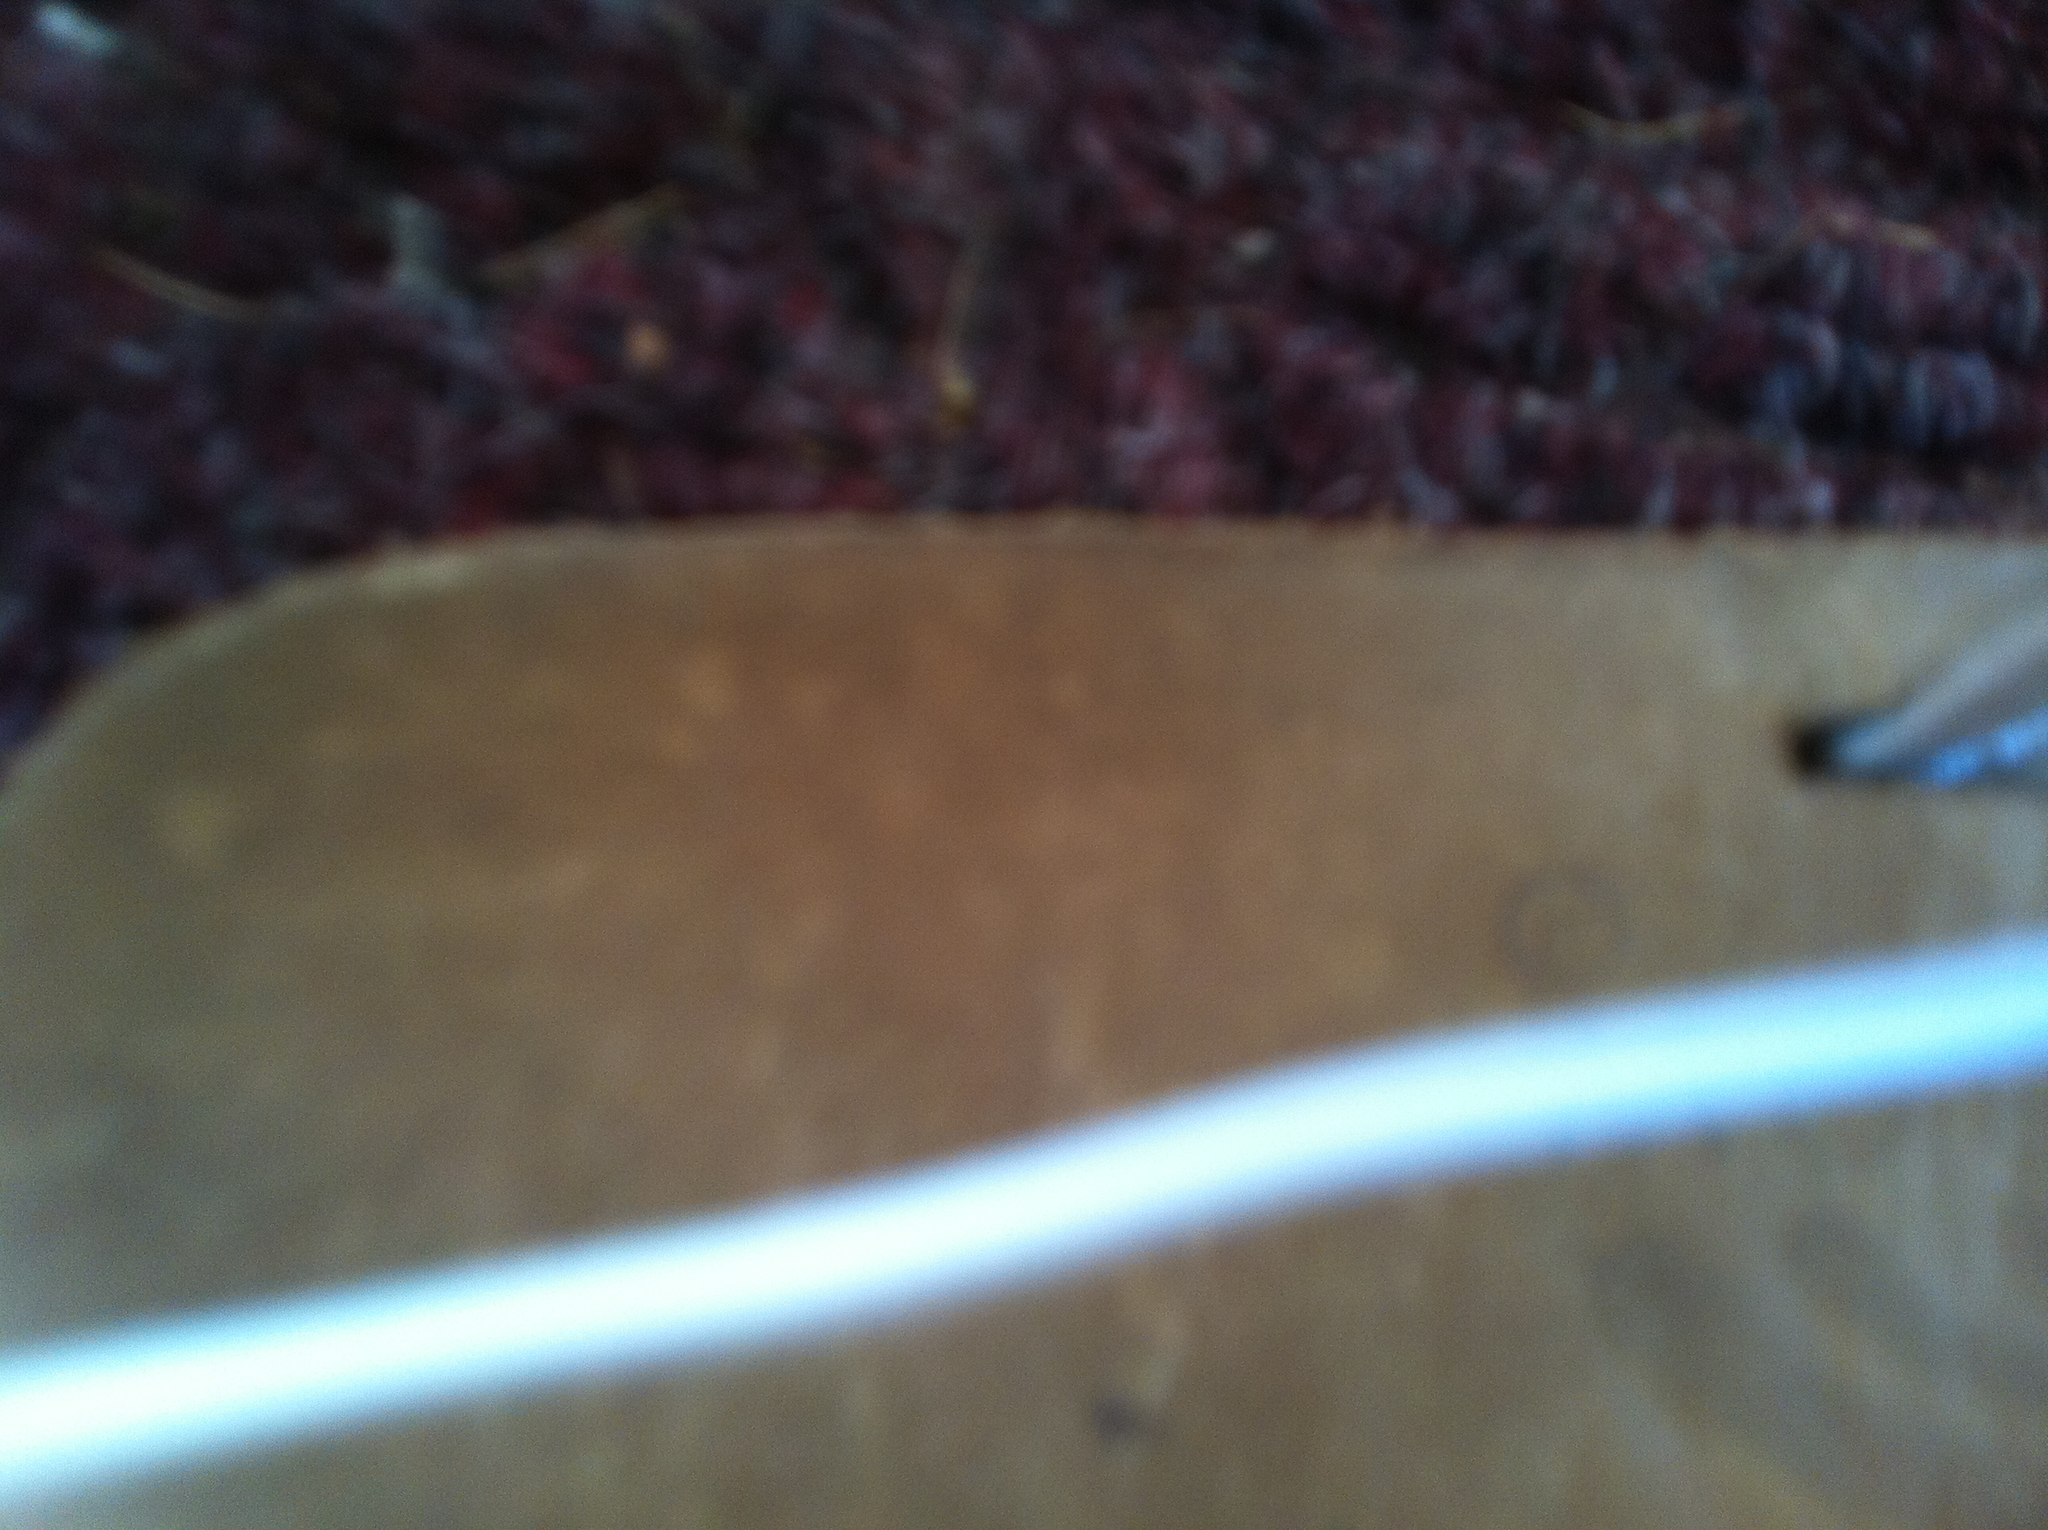What color is this shoe? The image is quite blurry, making it difficult to accurately determine the color of the shoe. However, based on visible parts, the shoe might have shades of brown and beige. 